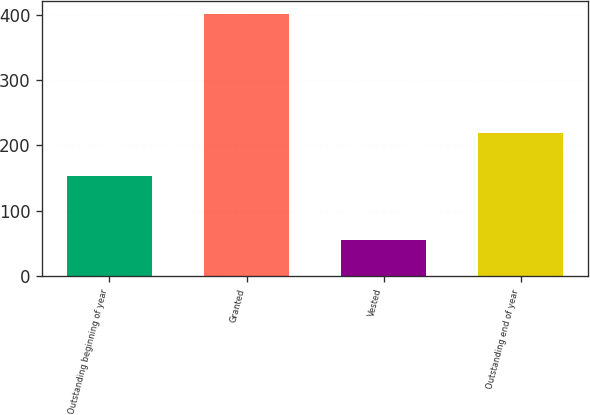<chart> <loc_0><loc_0><loc_500><loc_500><bar_chart><fcel>Outstanding beginning of year<fcel>Granted<fcel>Vested<fcel>Outstanding end of year<nl><fcel>153.4<fcel>401.56<fcel>55.92<fcel>218.34<nl></chart> 